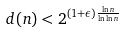Convert formula to latex. <formula><loc_0><loc_0><loc_500><loc_500>d ( n ) < 2 ^ { ( 1 + \epsilon ) \frac { \ln n } { \ln \ln n } }</formula> 